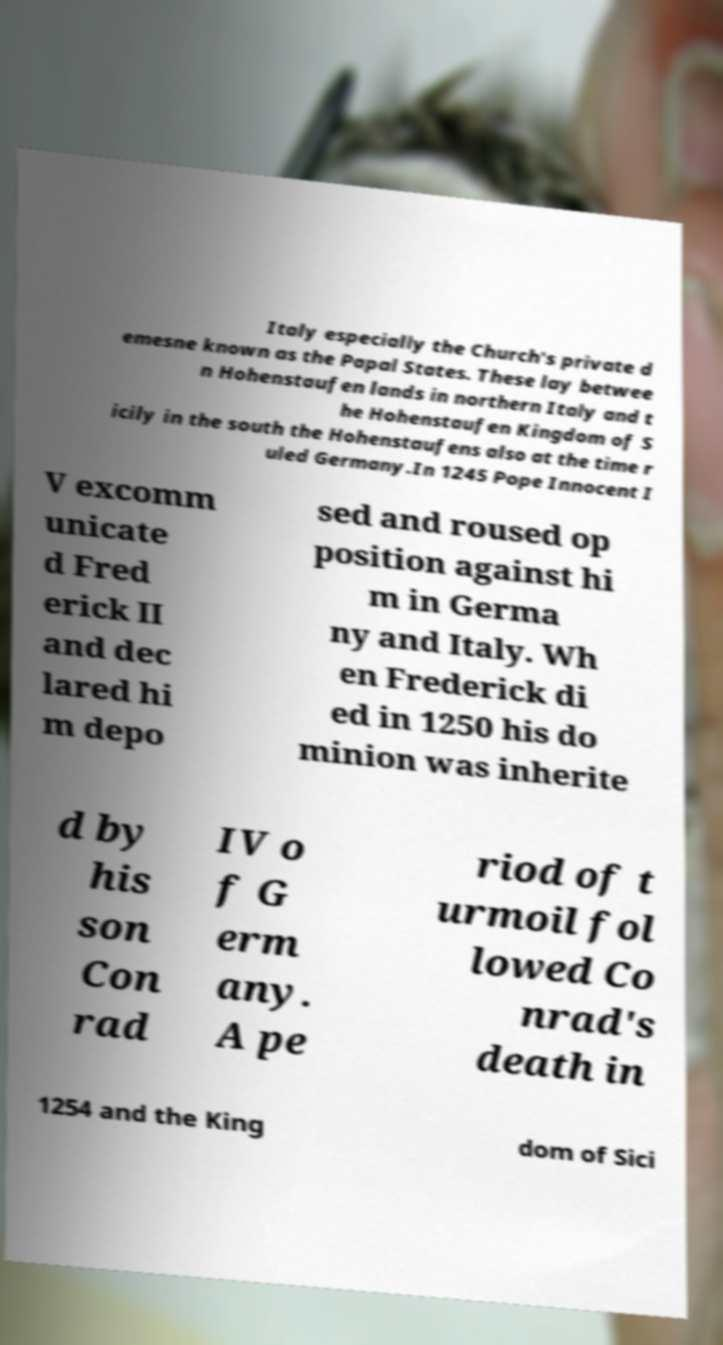For documentation purposes, I need the text within this image transcribed. Could you provide that? Italy especially the Church's private d emesne known as the Papal States. These lay betwee n Hohenstaufen lands in northern Italy and t he Hohenstaufen Kingdom of S icily in the south the Hohenstaufens also at the time r uled Germany.In 1245 Pope Innocent I V excomm unicate d Fred erick II and dec lared hi m depo sed and roused op position against hi m in Germa ny and Italy. Wh en Frederick di ed in 1250 his do minion was inherite d by his son Con rad IV o f G erm any. A pe riod of t urmoil fol lowed Co nrad's death in 1254 and the King dom of Sici 